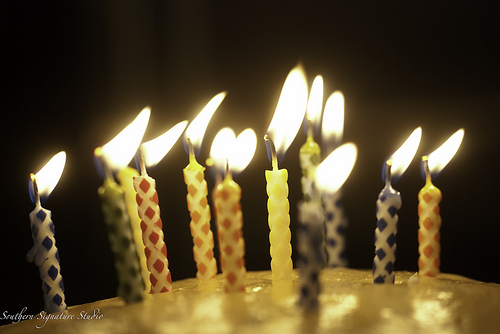<image>
Is there a red candle behind the orange candle? No. The red candle is not behind the orange candle. From this viewpoint, the red candle appears to be positioned elsewhere in the scene. 